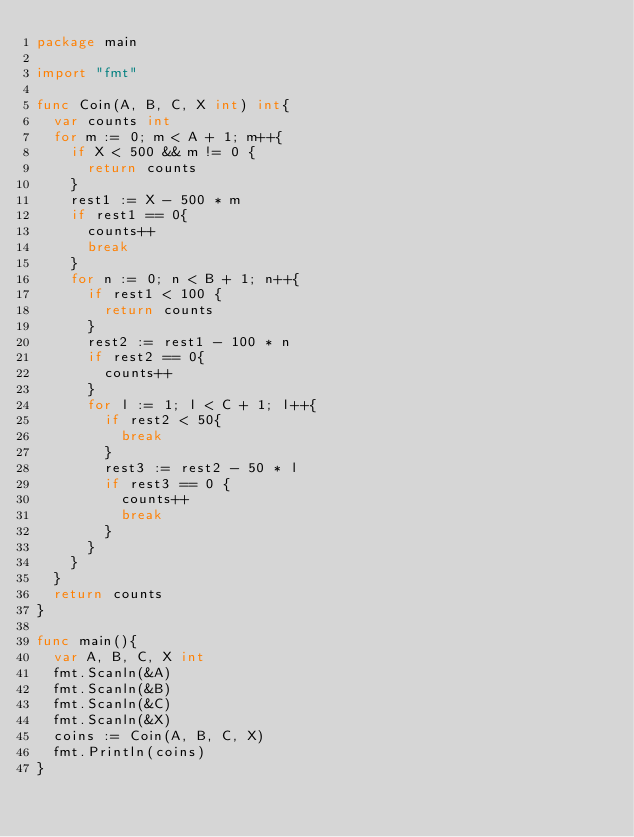Convert code to text. <code><loc_0><loc_0><loc_500><loc_500><_Go_>package main

import "fmt"

func Coin(A, B, C, X int) int{
	var counts int
	for m := 0; m < A + 1; m++{
		if X < 500 && m != 0 {
			return counts
		}
		rest1 := X - 500 * m
		if rest1 == 0{
			counts++
			break
		}
		for n := 0; n < B + 1; n++{
			if rest1 < 100 {
				return counts
			}
			rest2 := rest1 - 100 * n
			if rest2 == 0{
				counts++
			}
			for l := 1; l < C + 1; l++{
				if rest2 < 50{
					break
				}
				rest3 := rest2 - 50 * l
				if rest3 == 0 {
					counts++
					break
				}
			}
		}
	}
	return counts
}

func main(){
	var A, B, C, X int
	fmt.Scanln(&A)
	fmt.Scanln(&B)
	fmt.Scanln(&C)
	fmt.Scanln(&X)
	coins := Coin(A, B, C, X)
	fmt.Println(coins)
}</code> 